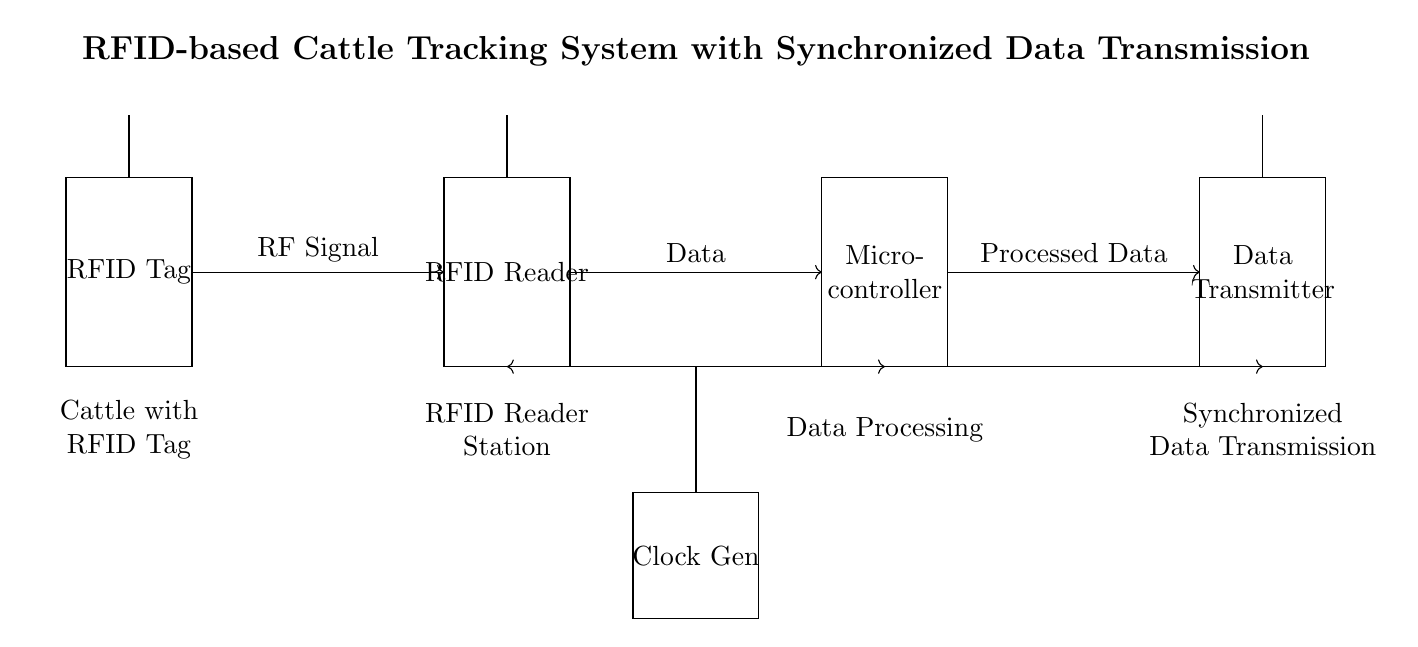What component represents the RFID reader? The component representing the RFID reader is the labeled rectangle in the diagram, specifically between the coordinates (6,0) and (8,3).
Answer: RFID Reader What is the role of the clock generator in this circuit? The clock generator synchronizes the data transmission by providing timing signals. It connects to the microcontroller and data transmitter, ensuring that data is sent at synchronized intervals.
Answer: Synchronization How many main components are present in this circuit diagram? The main components are the RFID Tag, RFID Reader, Microcontroller, Data Transmitter, and Clock Generator, totaling five components.
Answer: Five Where does the data processing occur? Data processing occurs in the microcontroller, as indicated by the labeled rectangle between coordinates (12,0) and (14,3).
Answer: Microcontroller What type of signal is transmitted from the RFID reader to the microcontroller? The signal transmitted is the data signal, conveyed from the RFID reader to the microcontroller as indicated by the arrow and labeled "Data".
Answer: Data How does the RFID tag communicate with the RFID reader? The RFID tag communicates with the RFID reader through RF signals, which are shown by the directional arrow connecting the RFID Tag and RFID Reader.
Answer: RF Signal What is the purpose of synchronized data transmission in this system? Synchronized data transmission allows for timely and accurate data transfer to track cattle efficiently, ensuring all components operate harmoniously.
Answer: Efficient tracking 